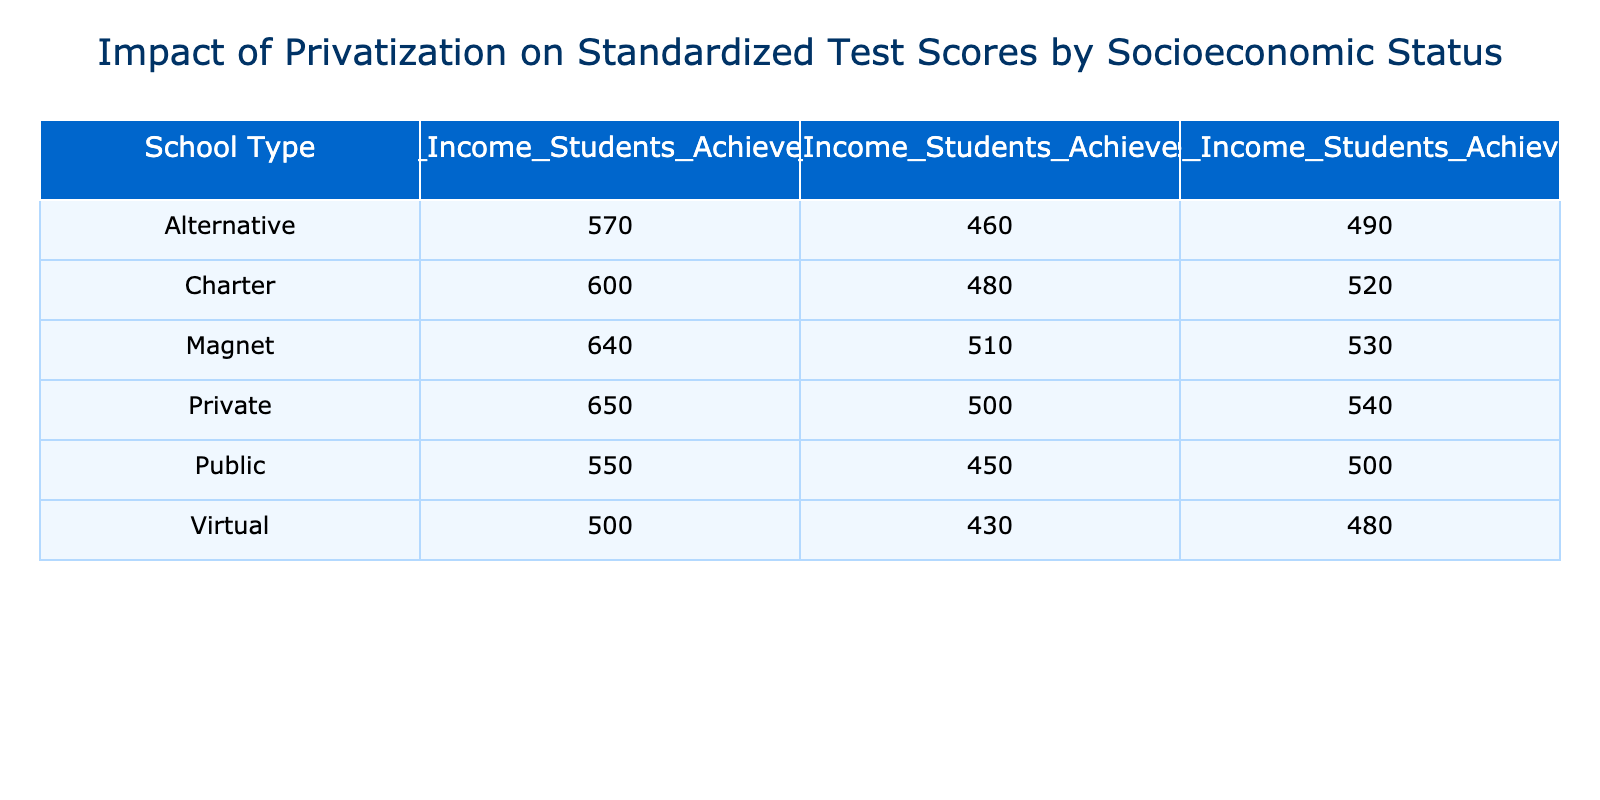What is the achievement score for Low Income Students in Private schools? The table lists Private schools under the row for "Private." Specifically, under the column for "Low Income Students Achievement," the score is 500.
Answer: 500 What is the highest achievement score among High Income Students regardless of school type? By examining the "High Income Students Achievement" column in the table, the scores are: Public (550), Charter (600), Private (650), Magnet (640), Virtual (500), Alternative (570). The highest value is 650 from Private schools.
Answer: 650 Which school type has the lowest achievement score for Middle Income Students? Reviewing the "Middle Income Students Achievement" column, the school types and their respective scores are: Public (500), Charter (520), Private (540), Magnet (530), Virtual (480), and Alternative (490). The lowest score, found in the Virtual row, is 480.
Answer: Virtual What is the average achievement score for Low Income Students across all school types? To calculate the average, sum the scores for Low Income Students: 450 (Public) + 480 (Charter) + 500 (Private) + 510 (Magnet) + 430 (Virtual) + 460 (Alternative) = 2630. There are 6 school types, so the average is 2630 / 6 = 438.33.
Answer: 438.33 Is it true that Charter schools have a higher achievement score for Low Income Students compared to Public schools? The Low Income Students Achievement in Charter schools is 480, while in Public schools it is 450. Since 480 is greater than 450, the statement is true.
Answer: Yes Which school type shows the greatest improvement in student achievement for High Income Students compared to Public schools? The High Income Students scores are: Public (550), Charter (600), Private (650), Magnet (640), Virtual (500), and Alternative (570). The improvements from Public are: Charter (+50), Private (+100), Magnet (+90), Virtual (-50), Alternative (+20). Private schools have the greatest improvement of +100.
Answer: Private What is the difference in achievement scores for Middle Income Students between Magnet and Virtual schools? Looking at the Middle Income scores, Magnet schools score 530, and Virtual schools score 480. The difference is 530 - 480 = 50.
Answer: 50 Which socioeconomic group has the highest average achievement score across all school types? The scores for Low Income Students are 450, 480, 500, 510, 430, 460, summing to 2630 (average: 438.33). Middle Income scores are 500, 520, 540, 530, 480, 490, summing to 2560 (average: 426.67). High Income scores are 550, 600, 650, 640, 500, 570, summing to 4160 (average: 693.33). The highest average is for High Income Students at 693.33.
Answer: High Income Students 